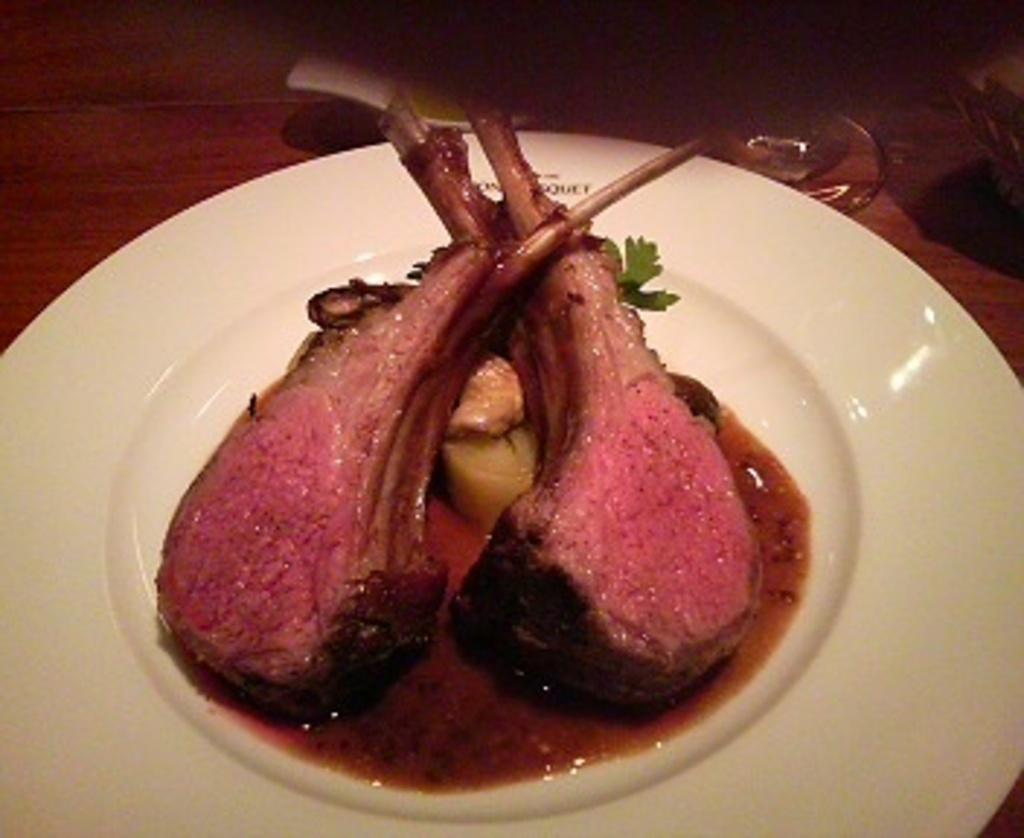What type of meat can be seen in the image? There are lamb chops in the image. What herb is present in the image? There is coriander leaf in the image. What is the white, creamy substance in the image? There is cream in the image. How is the food arranged in the image? The food is placed on a plate. Where is the plate located in the image? The plate is placed on a table. What type of pot is whistling on the page in the image? There is no pot or page present in the image; it features lamb chops, coriander leaf, cream, a plate, and a table. 